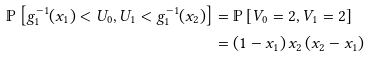<formula> <loc_0><loc_0><loc_500><loc_500>\mathbb { P } \left [ g _ { 1 } ^ { - 1 } ( x _ { 1 } ) < U _ { 0 } , U _ { 1 } < g _ { 1 } ^ { - 1 } ( x _ { 2 } ) \right ] & = \mathbb { P } \left [ V _ { 0 } = 2 , V _ { 1 } = 2 \right ] \\ & = \left ( 1 - x _ { 1 } \right ) x _ { 2 } \left ( x _ { 2 } - x _ { 1 } \right )</formula> 